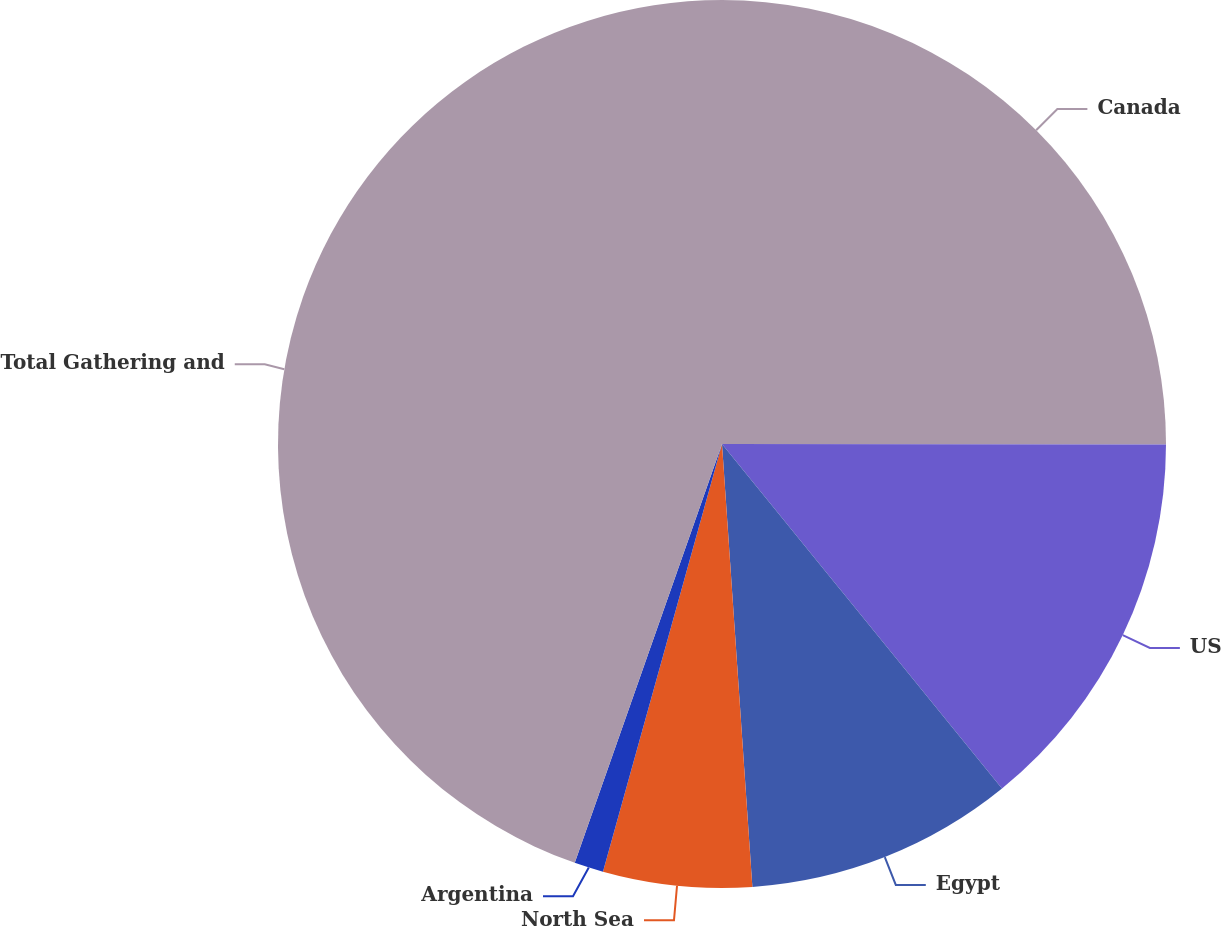Convert chart. <chart><loc_0><loc_0><loc_500><loc_500><pie_chart><fcel>Canada<fcel>US<fcel>Egypt<fcel>North Sea<fcel>Argentina<fcel>Total Gathering and<nl><fcel>25.02%<fcel>14.12%<fcel>9.77%<fcel>5.41%<fcel>1.06%<fcel>44.62%<nl></chart> 